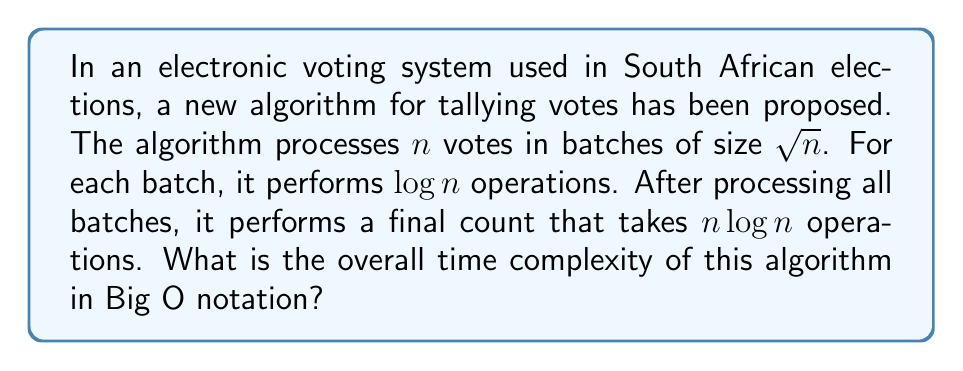Solve this math problem. Let's break this down step-by-step:

1) First, we need to determine how many batches there are:
   - Total votes: $n$
   - Batch size: $\sqrt{n}$
   - Number of batches: $n / \sqrt{n} = \sqrt{n}$

2) For each batch, the algorithm performs $\log n$ operations:
   - Operations per batch: $\log n$
   - Number of batches: $\sqrt{n}$
   - Total operations for all batches: $\sqrt{n} \cdot \log n$

3) After processing all batches, there's a final count taking $n\log n$ operations.

4) The total number of operations is the sum of steps 2 and 3:
   $$\sqrt{n} \cdot \log n + n\log n$$

5) Simplify:
   $$n\log n + \sqrt{n} \cdot \log n$$

6) In Big O notation, we keep only the fastest-growing term:
   - $n\log n$ grows faster than $\sqrt{n} \cdot \log n$
   - Therefore, the overall time complexity is $O(n\log n)$
Answer: $O(n\log n)$ 